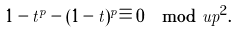Convert formula to latex. <formula><loc_0><loc_0><loc_500><loc_500>1 - t ^ { p } - ( 1 - t ) ^ { p } \equiv 0 \mod u p ^ { 2 } .</formula> 